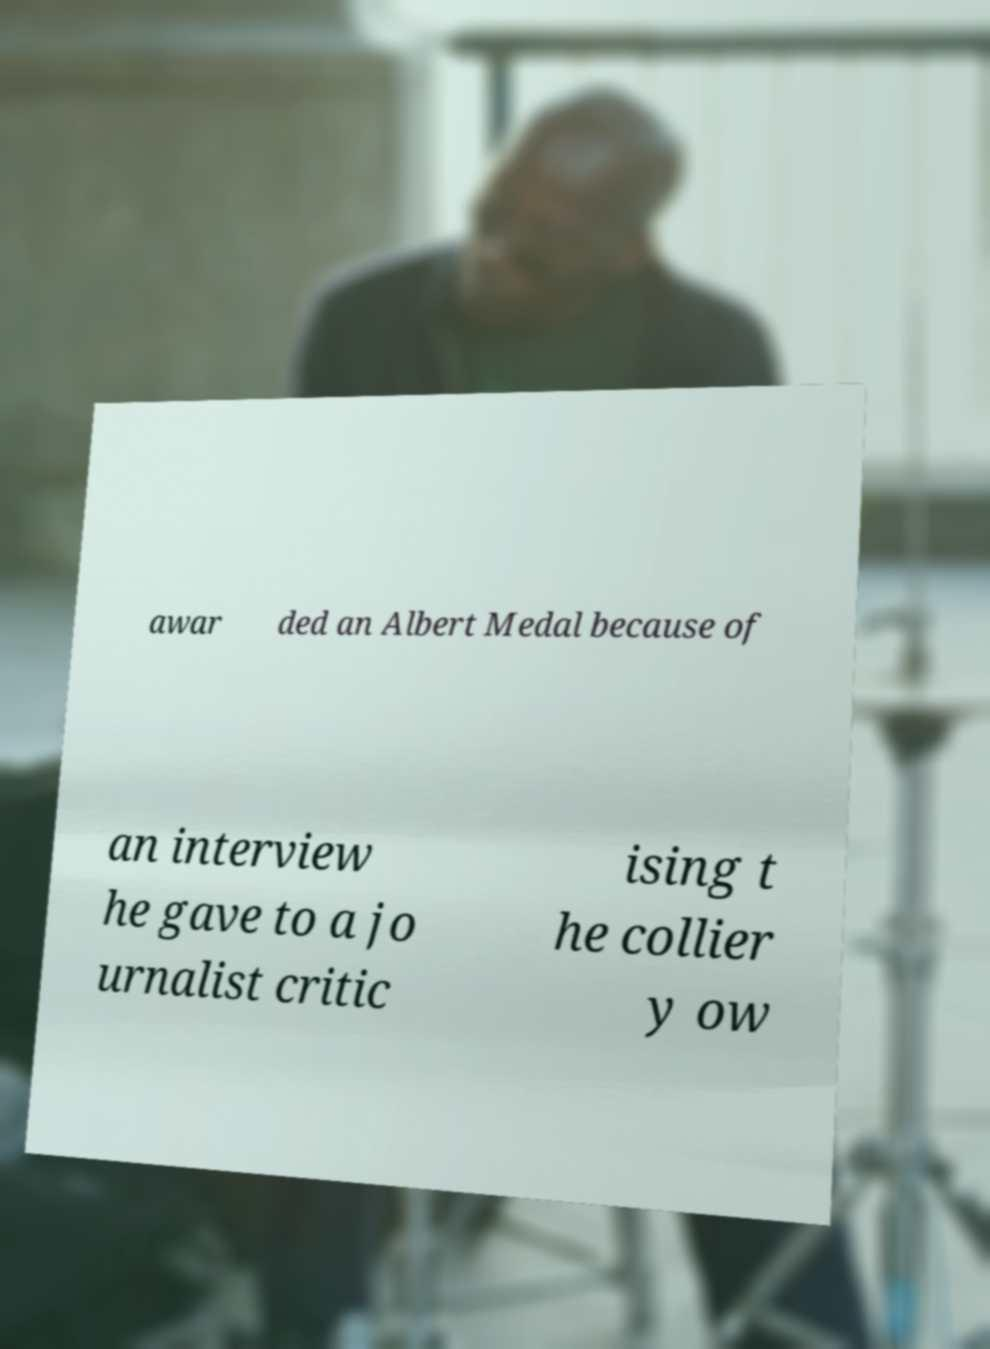I need the written content from this picture converted into text. Can you do that? awar ded an Albert Medal because of an interview he gave to a jo urnalist critic ising t he collier y ow 